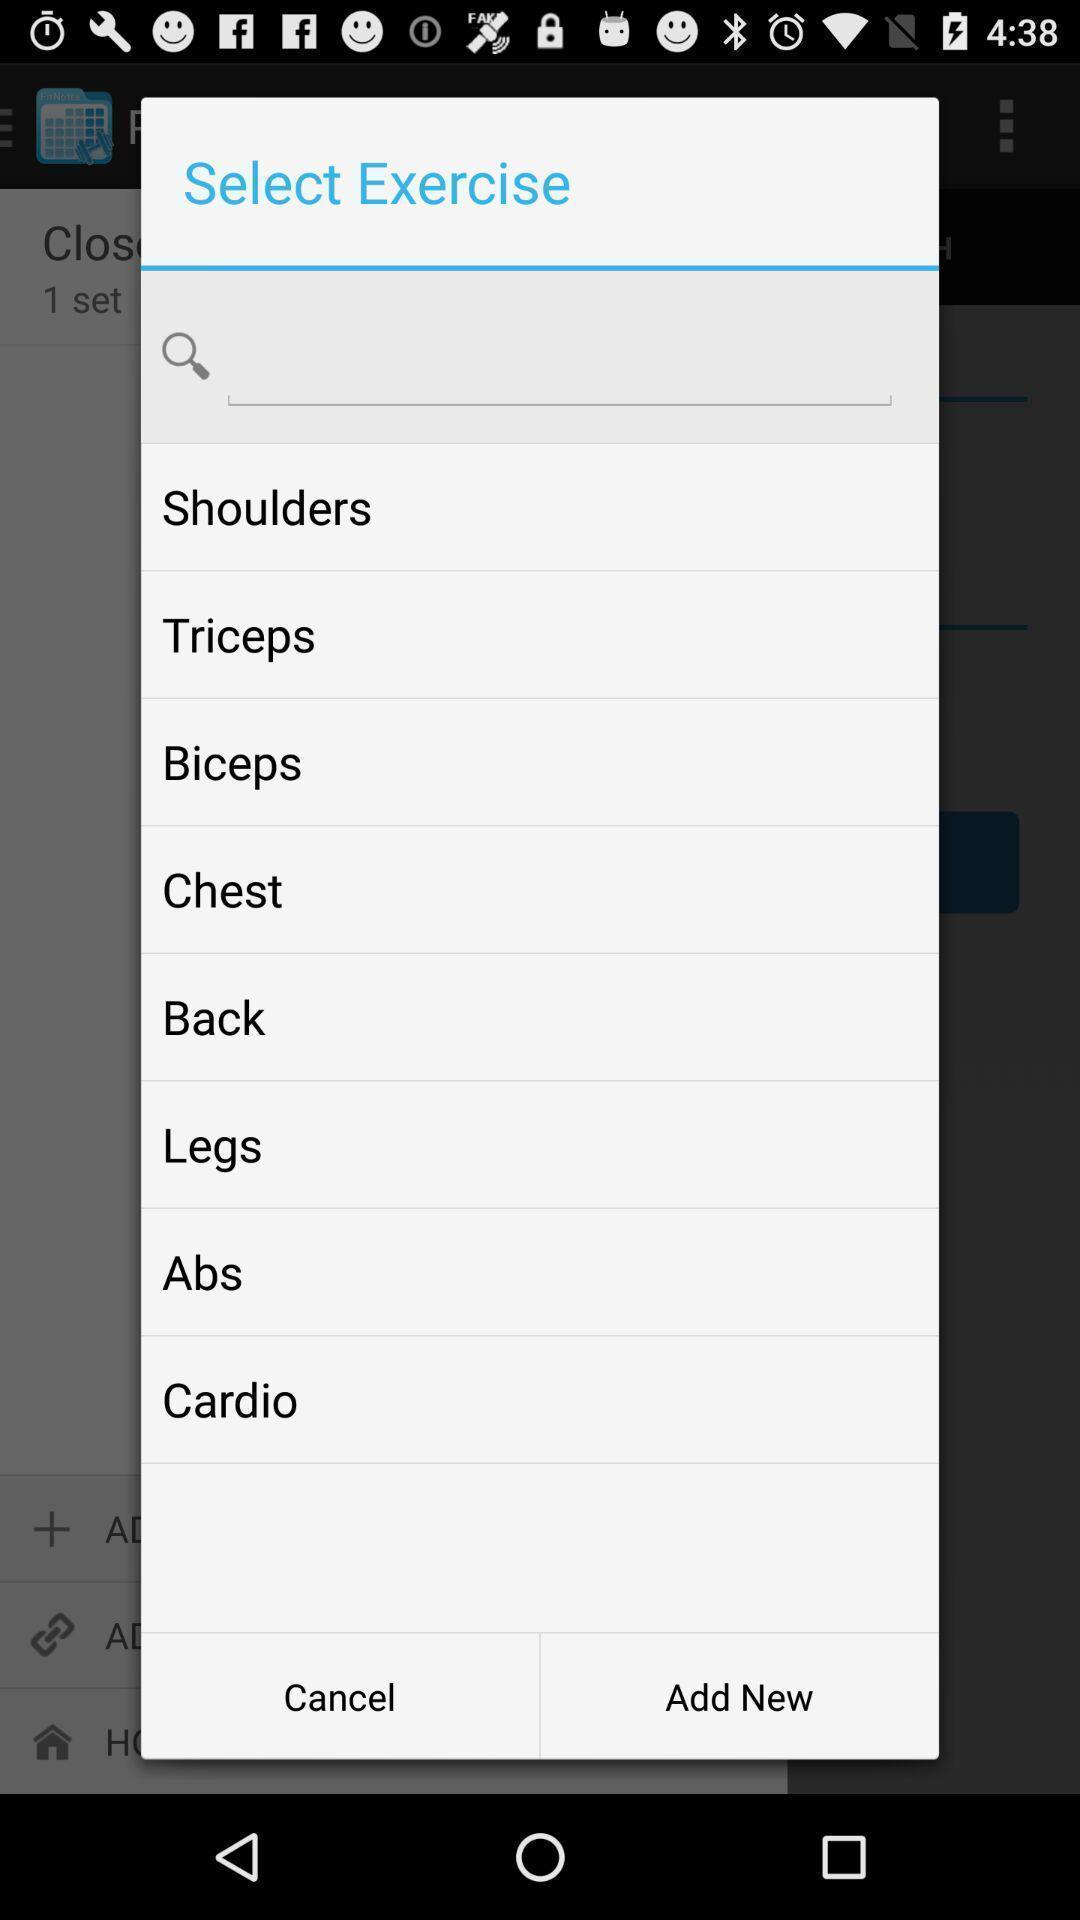Give me a summary of this screen capture. Screen shows list of exercises in workout application. 